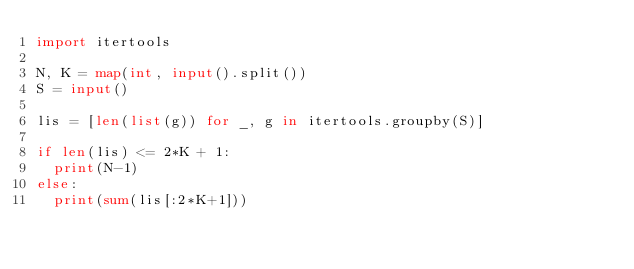<code> <loc_0><loc_0><loc_500><loc_500><_Python_>import itertools

N, K = map(int, input().split())
S = input()

lis = [len(list(g)) for _, g in itertools.groupby(S)]

if len(lis) <= 2*K + 1:
  print(N-1)
else:
  print(sum(lis[:2*K+1]))</code> 